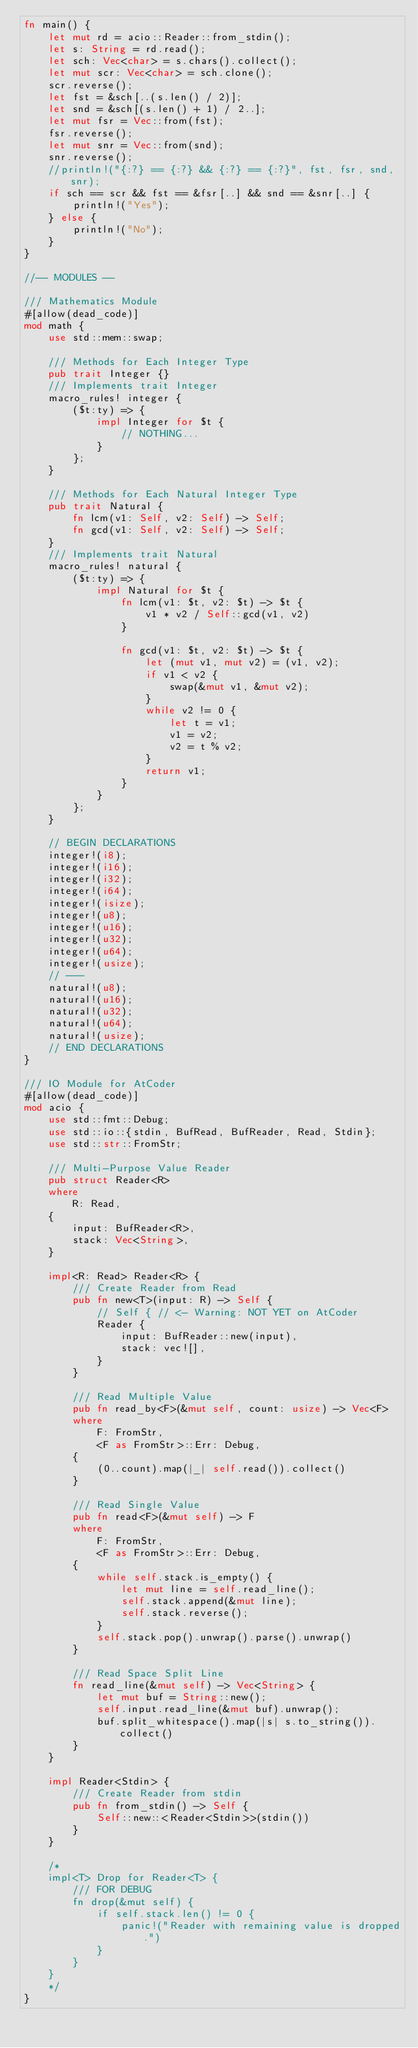Convert code to text. <code><loc_0><loc_0><loc_500><loc_500><_Rust_>fn main() {
    let mut rd = acio::Reader::from_stdin();
    let s: String = rd.read();
    let sch: Vec<char> = s.chars().collect();
    let mut scr: Vec<char> = sch.clone();
    scr.reverse();
    let fst = &sch[..(s.len() / 2)];
    let snd = &sch[(s.len() + 1) / 2..];
    let mut fsr = Vec::from(fst);
    fsr.reverse();
    let mut snr = Vec::from(snd);
    snr.reverse();
    //println!("{:?} == {:?} && {:?} == {:?}", fst, fsr, snd, snr);
    if sch == scr && fst == &fsr[..] && snd == &snr[..] {
        println!("Yes");
    } else {
        println!("No");
    }
}

//-- MODULES --

/// Mathematics Module
#[allow(dead_code)]
mod math {
    use std::mem::swap;

    /// Methods for Each Integer Type
    pub trait Integer {}
    /// Implements trait Integer
    macro_rules! integer {
        ($t:ty) => {
            impl Integer for $t {
                // NOTHING...
            }
        };
    }

    /// Methods for Each Natural Integer Type
    pub trait Natural {
        fn lcm(v1: Self, v2: Self) -> Self;
        fn gcd(v1: Self, v2: Self) -> Self;
    }
    /// Implements trait Natural
    macro_rules! natural {
        ($t:ty) => {
            impl Natural for $t {
                fn lcm(v1: $t, v2: $t) -> $t {
                    v1 * v2 / Self::gcd(v1, v2)
                }

                fn gcd(v1: $t, v2: $t) -> $t {
                    let (mut v1, mut v2) = (v1, v2);
                    if v1 < v2 {
                        swap(&mut v1, &mut v2);
                    }
                    while v2 != 0 {
                        let t = v1;
                        v1 = v2;
                        v2 = t % v2;
                    }
                    return v1;
                }
            }
        };
    }

    // BEGIN DECLARATIONS
    integer!(i8);
    integer!(i16);
    integer!(i32);
    integer!(i64);
    integer!(isize);
    integer!(u8);
    integer!(u16);
    integer!(u32);
    integer!(u64);
    integer!(usize);
    // ---
    natural!(u8);
    natural!(u16);
    natural!(u32);
    natural!(u64);
    natural!(usize);
    // END DECLARATIONS
}

/// IO Module for AtCoder
#[allow(dead_code)]
mod acio {
    use std::fmt::Debug;
    use std::io::{stdin, BufRead, BufReader, Read, Stdin};
    use std::str::FromStr;

    /// Multi-Purpose Value Reader
    pub struct Reader<R>
    where
        R: Read,
    {
        input: BufReader<R>,
        stack: Vec<String>,
    }

    impl<R: Read> Reader<R> {
        /// Create Reader from Read
        pub fn new<T>(input: R) -> Self {
            // Self { // <- Warning: NOT YET on AtCoder
            Reader {
                input: BufReader::new(input),
                stack: vec![],
            }
        }

        /// Read Multiple Value
        pub fn read_by<F>(&mut self, count: usize) -> Vec<F>
        where
            F: FromStr,
            <F as FromStr>::Err: Debug,
        {
            (0..count).map(|_| self.read()).collect()
        }

        /// Read Single Value
        pub fn read<F>(&mut self) -> F
        where
            F: FromStr,
            <F as FromStr>::Err: Debug,
        {
            while self.stack.is_empty() {
                let mut line = self.read_line();
                self.stack.append(&mut line);
                self.stack.reverse();
            }
            self.stack.pop().unwrap().parse().unwrap()
        }

        /// Read Space Split Line
        fn read_line(&mut self) -> Vec<String> {
            let mut buf = String::new();
            self.input.read_line(&mut buf).unwrap();
            buf.split_whitespace().map(|s| s.to_string()).collect()
        }
    }

    impl Reader<Stdin> {
        /// Create Reader from stdin
        pub fn from_stdin() -> Self {
            Self::new::<Reader<Stdin>>(stdin())
        }
    }

    /*
    impl<T> Drop for Reader<T> {
        /// FOR DEBUG
        fn drop(&mut self) {
            if self.stack.len() != 0 {
                panic!("Reader with remaining value is dropped.")
            }
        }
    }
    */
}
</code> 